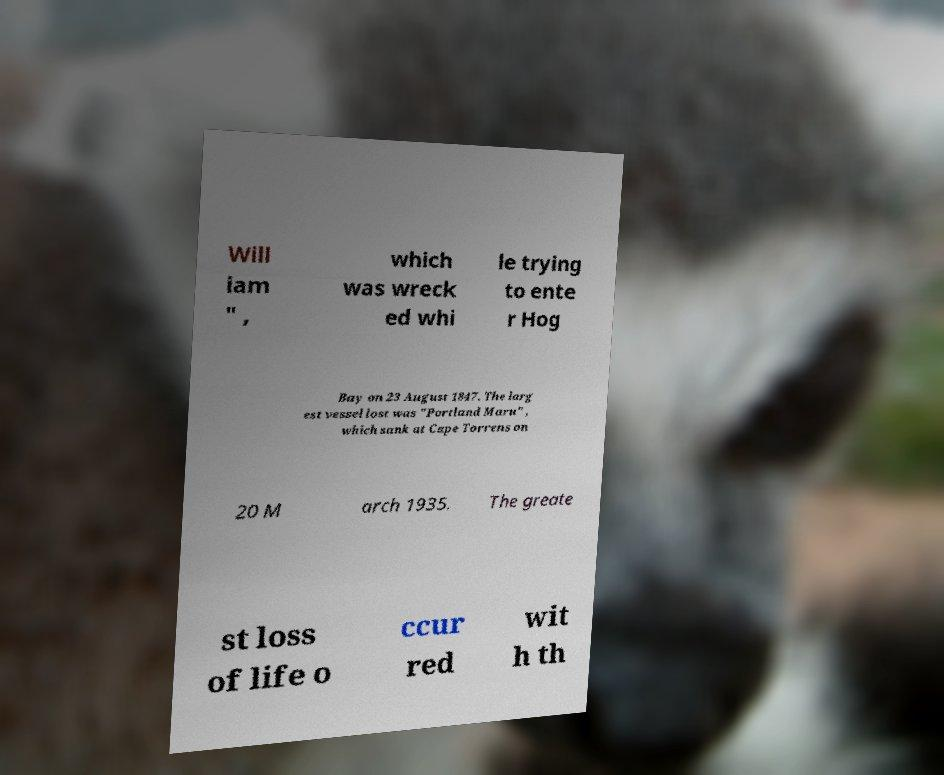Can you accurately transcribe the text from the provided image for me? Will iam " , which was wreck ed whi le trying to ente r Hog Bay on 23 August 1847. The larg est vessel lost was "Portland Maru" , which sank at Cape Torrens on 20 M arch 1935. The greate st loss of life o ccur red wit h th 